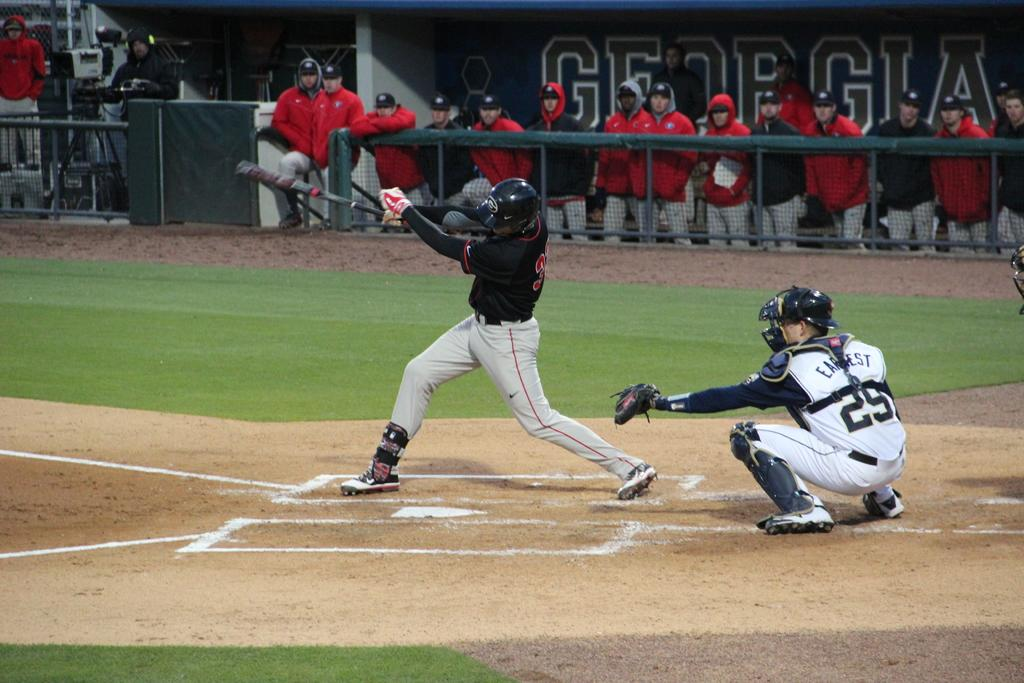<image>
Create a compact narrative representing the image presented. A baseball batter swings at a pitch at a Georgia game. 